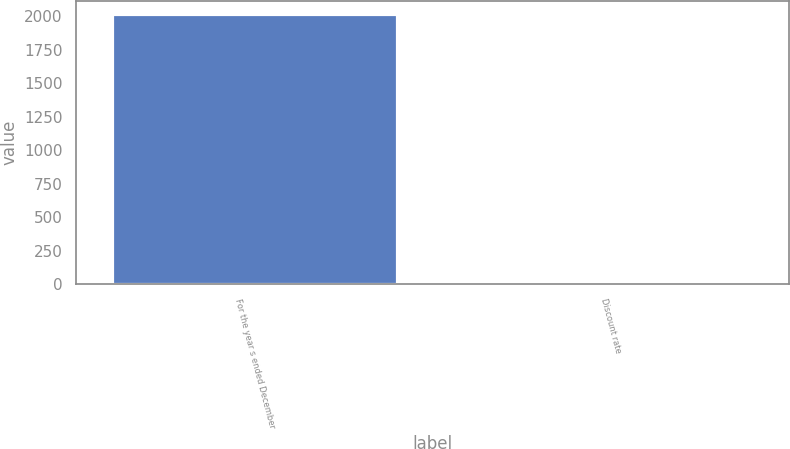<chart> <loc_0><loc_0><loc_500><loc_500><bar_chart><fcel>For the year s ended December<fcel>Discount rate<nl><fcel>2012<fcel>4.5<nl></chart> 